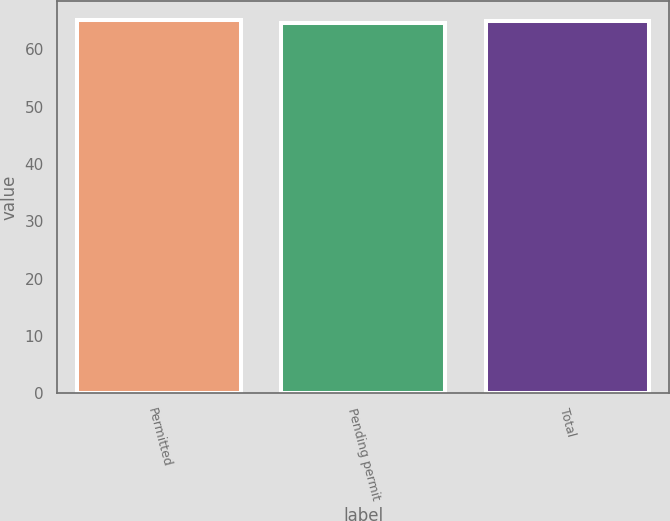<chart> <loc_0><loc_0><loc_500><loc_500><bar_chart><fcel>Permitted<fcel>Pending permit<fcel>Total<nl><fcel>65.21<fcel>64.63<fcel>64.93<nl></chart> 